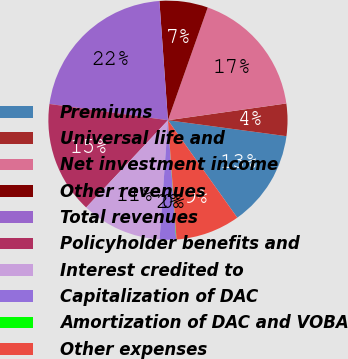Convert chart to OTSL. <chart><loc_0><loc_0><loc_500><loc_500><pie_chart><fcel>Premiums<fcel>Universal life and<fcel>Net investment income<fcel>Other revenues<fcel>Total revenues<fcel>Policyholder benefits and<fcel>Interest credited to<fcel>Capitalization of DAC<fcel>Amortization of DAC and VOBA<fcel>Other expenses<nl><fcel>13.03%<fcel>4.37%<fcel>17.36%<fcel>6.54%<fcel>21.69%<fcel>15.19%<fcel>10.87%<fcel>2.21%<fcel>0.05%<fcel>8.7%<nl></chart> 